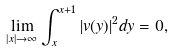<formula> <loc_0><loc_0><loc_500><loc_500>\lim _ { | x | \to \infty } \int _ { x } ^ { x + 1 } | v ( y ) | ^ { 2 } d y = 0 ,</formula> 